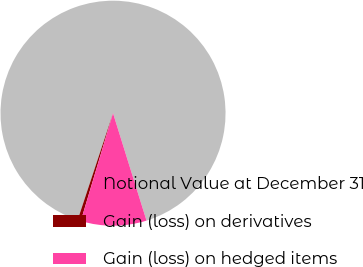Convert chart to OTSL. <chart><loc_0><loc_0><loc_500><loc_500><pie_chart><fcel>Notional Value at December 31<fcel>Gain (loss) on derivatives<fcel>Gain (loss) on hedged items<nl><fcel>90.09%<fcel>0.47%<fcel>9.43%<nl></chart> 